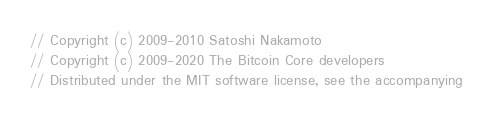<code> <loc_0><loc_0><loc_500><loc_500><_C++_>// Copyright (c) 2009-2010 Satoshi Nakamoto
// Copyright (c) 2009-2020 The Bitcoin Core developers
// Distributed under the MIT software license, see the accompanying</code> 